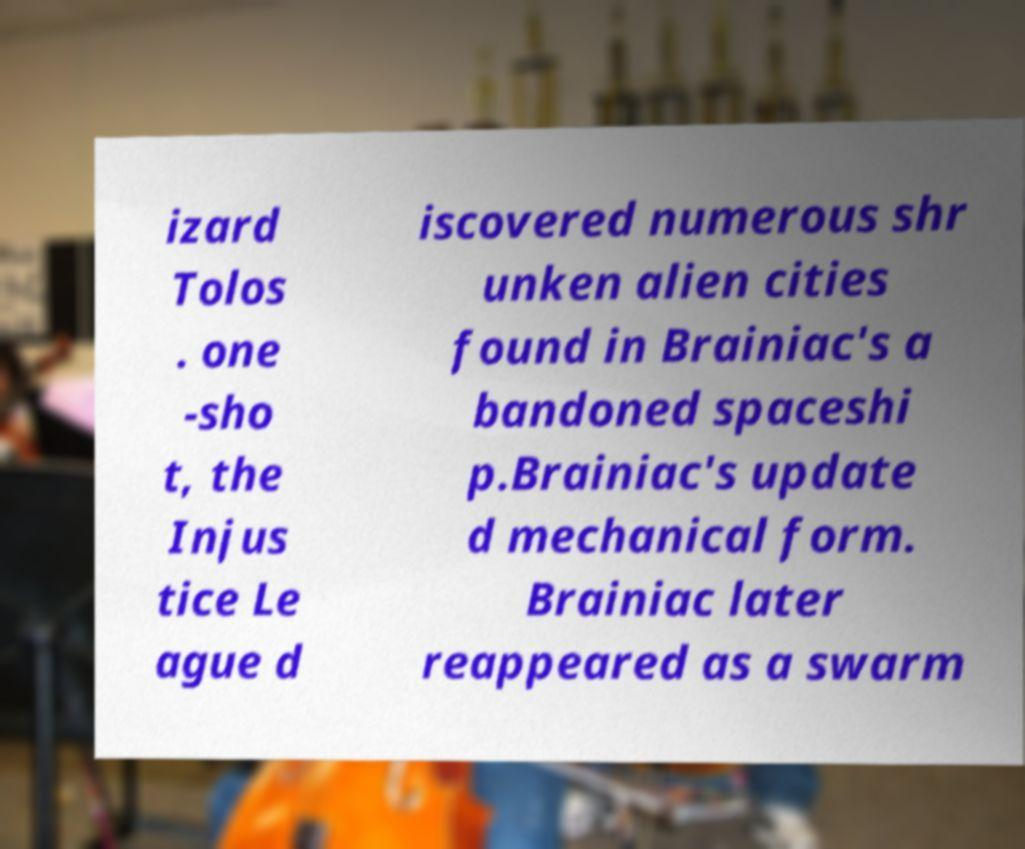There's text embedded in this image that I need extracted. Can you transcribe it verbatim? izard Tolos . one -sho t, the Injus tice Le ague d iscovered numerous shr unken alien cities found in Brainiac's a bandoned spaceshi p.Brainiac's update d mechanical form. Brainiac later reappeared as a swarm 